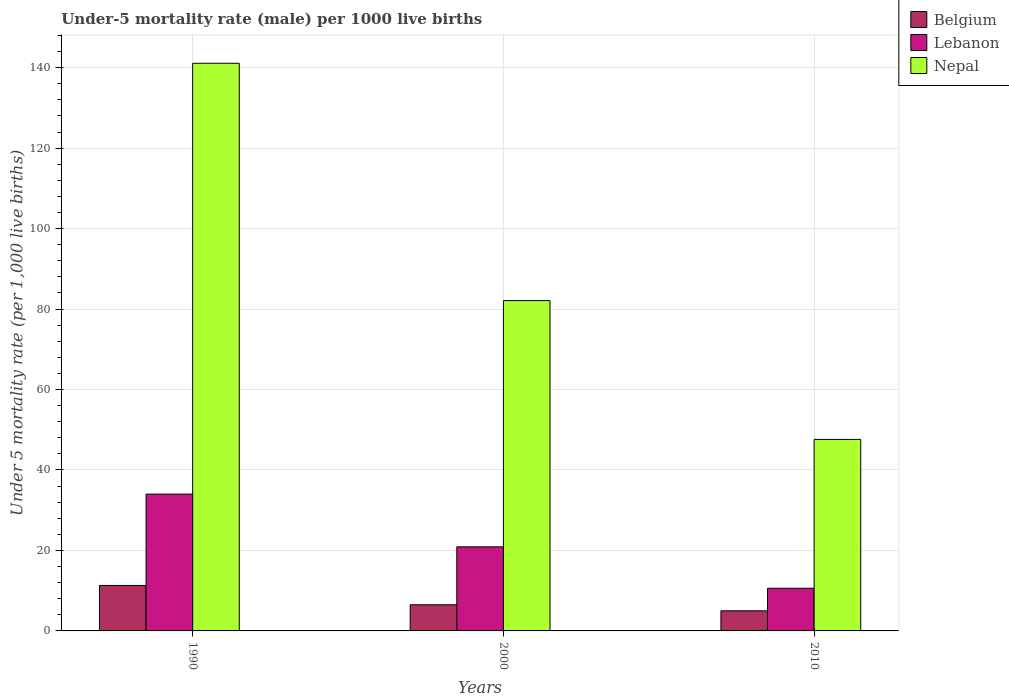How many bars are there on the 1st tick from the left?
Your answer should be compact. 3. What is the label of the 1st group of bars from the left?
Ensure brevity in your answer.  1990. In how many cases, is the number of bars for a given year not equal to the number of legend labels?
Offer a very short reply. 0. Across all years, what is the maximum under-five mortality rate in Nepal?
Provide a short and direct response. 141.1. Across all years, what is the minimum under-five mortality rate in Nepal?
Offer a terse response. 47.6. What is the total under-five mortality rate in Belgium in the graph?
Your response must be concise. 22.8. What is the difference between the under-five mortality rate in Belgium in 2000 and that in 2010?
Provide a succinct answer. 1.5. What is the difference between the under-five mortality rate in Nepal in 2010 and the under-five mortality rate in Belgium in 1990?
Your answer should be very brief. 36.3. What is the average under-five mortality rate in Nepal per year?
Provide a short and direct response. 90.27. In the year 2010, what is the difference between the under-five mortality rate in Belgium and under-five mortality rate in Nepal?
Ensure brevity in your answer.  -42.6. In how many years, is the under-five mortality rate in Belgium greater than 8?
Keep it short and to the point. 1. What is the ratio of the under-five mortality rate in Lebanon in 1990 to that in 2000?
Your answer should be compact. 1.63. Is the under-five mortality rate in Nepal in 2000 less than that in 2010?
Your response must be concise. No. What is the difference between the highest and the second highest under-five mortality rate in Lebanon?
Make the answer very short. 13.1. What is the difference between the highest and the lowest under-five mortality rate in Nepal?
Provide a succinct answer. 93.5. What does the 2nd bar from the right in 2000 represents?
Your answer should be compact. Lebanon. Is it the case that in every year, the sum of the under-five mortality rate in Nepal and under-five mortality rate in Belgium is greater than the under-five mortality rate in Lebanon?
Ensure brevity in your answer.  Yes. Are all the bars in the graph horizontal?
Provide a succinct answer. No. What is the difference between two consecutive major ticks on the Y-axis?
Offer a very short reply. 20. Are the values on the major ticks of Y-axis written in scientific E-notation?
Provide a short and direct response. No. Does the graph contain any zero values?
Your response must be concise. No. Where does the legend appear in the graph?
Make the answer very short. Top right. What is the title of the graph?
Provide a succinct answer. Under-5 mortality rate (male) per 1000 live births. Does "Namibia" appear as one of the legend labels in the graph?
Give a very brief answer. No. What is the label or title of the X-axis?
Offer a terse response. Years. What is the label or title of the Y-axis?
Make the answer very short. Under 5 mortality rate (per 1,0 live births). What is the Under 5 mortality rate (per 1,000 live births) in Lebanon in 1990?
Your answer should be very brief. 34. What is the Under 5 mortality rate (per 1,000 live births) of Nepal in 1990?
Your answer should be compact. 141.1. What is the Under 5 mortality rate (per 1,000 live births) of Belgium in 2000?
Your response must be concise. 6.5. What is the Under 5 mortality rate (per 1,000 live births) of Lebanon in 2000?
Keep it short and to the point. 20.9. What is the Under 5 mortality rate (per 1,000 live births) of Nepal in 2000?
Make the answer very short. 82.1. What is the Under 5 mortality rate (per 1,000 live births) in Belgium in 2010?
Your response must be concise. 5. What is the Under 5 mortality rate (per 1,000 live births) of Lebanon in 2010?
Provide a short and direct response. 10.6. What is the Under 5 mortality rate (per 1,000 live births) of Nepal in 2010?
Provide a succinct answer. 47.6. Across all years, what is the maximum Under 5 mortality rate (per 1,000 live births) of Belgium?
Give a very brief answer. 11.3. Across all years, what is the maximum Under 5 mortality rate (per 1,000 live births) of Nepal?
Offer a terse response. 141.1. Across all years, what is the minimum Under 5 mortality rate (per 1,000 live births) in Belgium?
Your response must be concise. 5. Across all years, what is the minimum Under 5 mortality rate (per 1,000 live births) of Nepal?
Your answer should be very brief. 47.6. What is the total Under 5 mortality rate (per 1,000 live births) in Belgium in the graph?
Provide a succinct answer. 22.8. What is the total Under 5 mortality rate (per 1,000 live births) in Lebanon in the graph?
Ensure brevity in your answer.  65.5. What is the total Under 5 mortality rate (per 1,000 live births) of Nepal in the graph?
Offer a terse response. 270.8. What is the difference between the Under 5 mortality rate (per 1,000 live births) of Belgium in 1990 and that in 2000?
Provide a succinct answer. 4.8. What is the difference between the Under 5 mortality rate (per 1,000 live births) of Lebanon in 1990 and that in 2000?
Keep it short and to the point. 13.1. What is the difference between the Under 5 mortality rate (per 1,000 live births) of Lebanon in 1990 and that in 2010?
Provide a short and direct response. 23.4. What is the difference between the Under 5 mortality rate (per 1,000 live births) in Nepal in 1990 and that in 2010?
Offer a terse response. 93.5. What is the difference between the Under 5 mortality rate (per 1,000 live births) in Belgium in 2000 and that in 2010?
Keep it short and to the point. 1.5. What is the difference between the Under 5 mortality rate (per 1,000 live births) in Lebanon in 2000 and that in 2010?
Ensure brevity in your answer.  10.3. What is the difference between the Under 5 mortality rate (per 1,000 live births) of Nepal in 2000 and that in 2010?
Your response must be concise. 34.5. What is the difference between the Under 5 mortality rate (per 1,000 live births) in Belgium in 1990 and the Under 5 mortality rate (per 1,000 live births) in Nepal in 2000?
Your answer should be very brief. -70.8. What is the difference between the Under 5 mortality rate (per 1,000 live births) of Lebanon in 1990 and the Under 5 mortality rate (per 1,000 live births) of Nepal in 2000?
Make the answer very short. -48.1. What is the difference between the Under 5 mortality rate (per 1,000 live births) of Belgium in 1990 and the Under 5 mortality rate (per 1,000 live births) of Lebanon in 2010?
Offer a very short reply. 0.7. What is the difference between the Under 5 mortality rate (per 1,000 live births) of Belgium in 1990 and the Under 5 mortality rate (per 1,000 live births) of Nepal in 2010?
Provide a succinct answer. -36.3. What is the difference between the Under 5 mortality rate (per 1,000 live births) of Belgium in 2000 and the Under 5 mortality rate (per 1,000 live births) of Nepal in 2010?
Offer a very short reply. -41.1. What is the difference between the Under 5 mortality rate (per 1,000 live births) of Lebanon in 2000 and the Under 5 mortality rate (per 1,000 live births) of Nepal in 2010?
Make the answer very short. -26.7. What is the average Under 5 mortality rate (per 1,000 live births) of Belgium per year?
Offer a terse response. 7.6. What is the average Under 5 mortality rate (per 1,000 live births) of Lebanon per year?
Offer a terse response. 21.83. What is the average Under 5 mortality rate (per 1,000 live births) in Nepal per year?
Provide a short and direct response. 90.27. In the year 1990, what is the difference between the Under 5 mortality rate (per 1,000 live births) of Belgium and Under 5 mortality rate (per 1,000 live births) of Lebanon?
Your response must be concise. -22.7. In the year 1990, what is the difference between the Under 5 mortality rate (per 1,000 live births) of Belgium and Under 5 mortality rate (per 1,000 live births) of Nepal?
Give a very brief answer. -129.8. In the year 1990, what is the difference between the Under 5 mortality rate (per 1,000 live births) of Lebanon and Under 5 mortality rate (per 1,000 live births) of Nepal?
Provide a short and direct response. -107.1. In the year 2000, what is the difference between the Under 5 mortality rate (per 1,000 live births) of Belgium and Under 5 mortality rate (per 1,000 live births) of Lebanon?
Offer a terse response. -14.4. In the year 2000, what is the difference between the Under 5 mortality rate (per 1,000 live births) of Belgium and Under 5 mortality rate (per 1,000 live births) of Nepal?
Offer a very short reply. -75.6. In the year 2000, what is the difference between the Under 5 mortality rate (per 1,000 live births) in Lebanon and Under 5 mortality rate (per 1,000 live births) in Nepal?
Make the answer very short. -61.2. In the year 2010, what is the difference between the Under 5 mortality rate (per 1,000 live births) in Belgium and Under 5 mortality rate (per 1,000 live births) in Nepal?
Your answer should be very brief. -42.6. In the year 2010, what is the difference between the Under 5 mortality rate (per 1,000 live births) of Lebanon and Under 5 mortality rate (per 1,000 live births) of Nepal?
Provide a succinct answer. -37. What is the ratio of the Under 5 mortality rate (per 1,000 live births) of Belgium in 1990 to that in 2000?
Provide a succinct answer. 1.74. What is the ratio of the Under 5 mortality rate (per 1,000 live births) of Lebanon in 1990 to that in 2000?
Provide a short and direct response. 1.63. What is the ratio of the Under 5 mortality rate (per 1,000 live births) of Nepal in 1990 to that in 2000?
Offer a terse response. 1.72. What is the ratio of the Under 5 mortality rate (per 1,000 live births) in Belgium in 1990 to that in 2010?
Keep it short and to the point. 2.26. What is the ratio of the Under 5 mortality rate (per 1,000 live births) in Lebanon in 1990 to that in 2010?
Keep it short and to the point. 3.21. What is the ratio of the Under 5 mortality rate (per 1,000 live births) in Nepal in 1990 to that in 2010?
Provide a succinct answer. 2.96. What is the ratio of the Under 5 mortality rate (per 1,000 live births) of Belgium in 2000 to that in 2010?
Your response must be concise. 1.3. What is the ratio of the Under 5 mortality rate (per 1,000 live births) of Lebanon in 2000 to that in 2010?
Provide a succinct answer. 1.97. What is the ratio of the Under 5 mortality rate (per 1,000 live births) in Nepal in 2000 to that in 2010?
Your response must be concise. 1.72. What is the difference between the highest and the second highest Under 5 mortality rate (per 1,000 live births) of Belgium?
Ensure brevity in your answer.  4.8. What is the difference between the highest and the second highest Under 5 mortality rate (per 1,000 live births) in Lebanon?
Ensure brevity in your answer.  13.1. What is the difference between the highest and the lowest Under 5 mortality rate (per 1,000 live births) of Belgium?
Make the answer very short. 6.3. What is the difference between the highest and the lowest Under 5 mortality rate (per 1,000 live births) of Lebanon?
Provide a short and direct response. 23.4. What is the difference between the highest and the lowest Under 5 mortality rate (per 1,000 live births) in Nepal?
Provide a succinct answer. 93.5. 